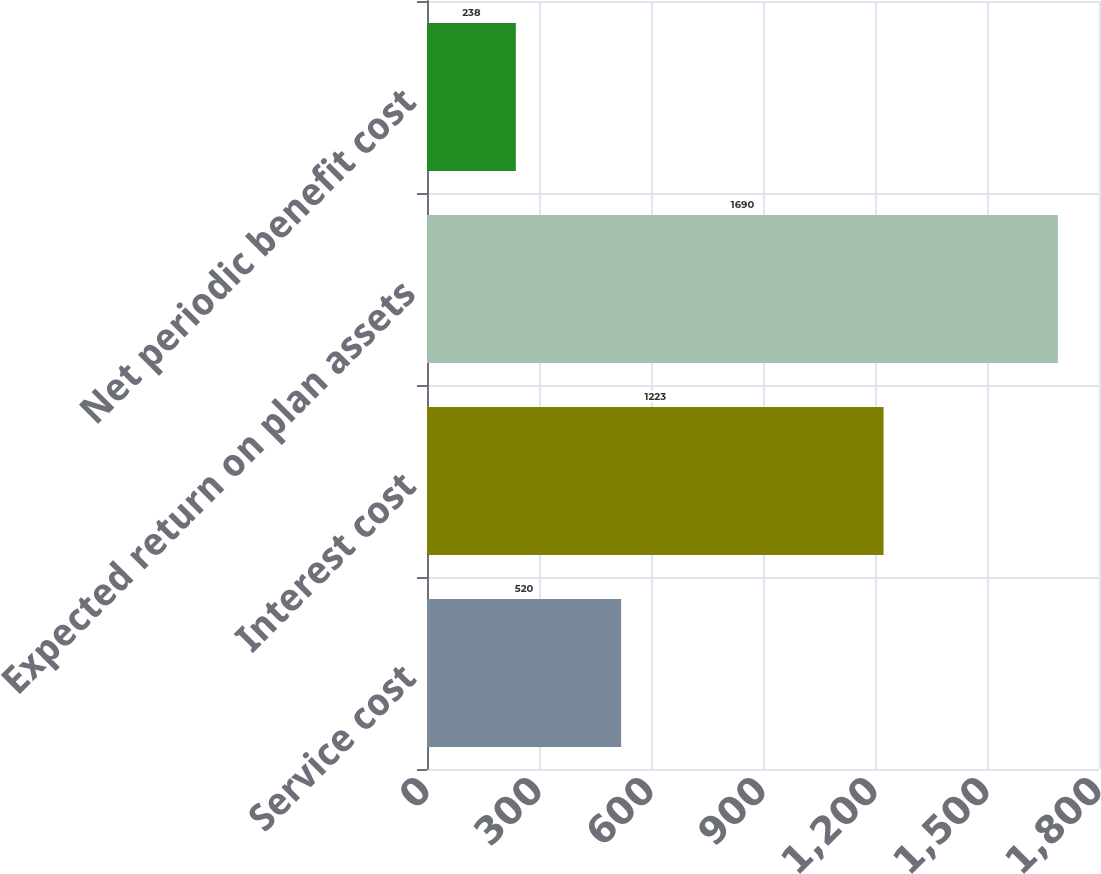Convert chart to OTSL. <chart><loc_0><loc_0><loc_500><loc_500><bar_chart><fcel>Service cost<fcel>Interest cost<fcel>Expected return on plan assets<fcel>Net periodic benefit cost<nl><fcel>520<fcel>1223<fcel>1690<fcel>238<nl></chart> 